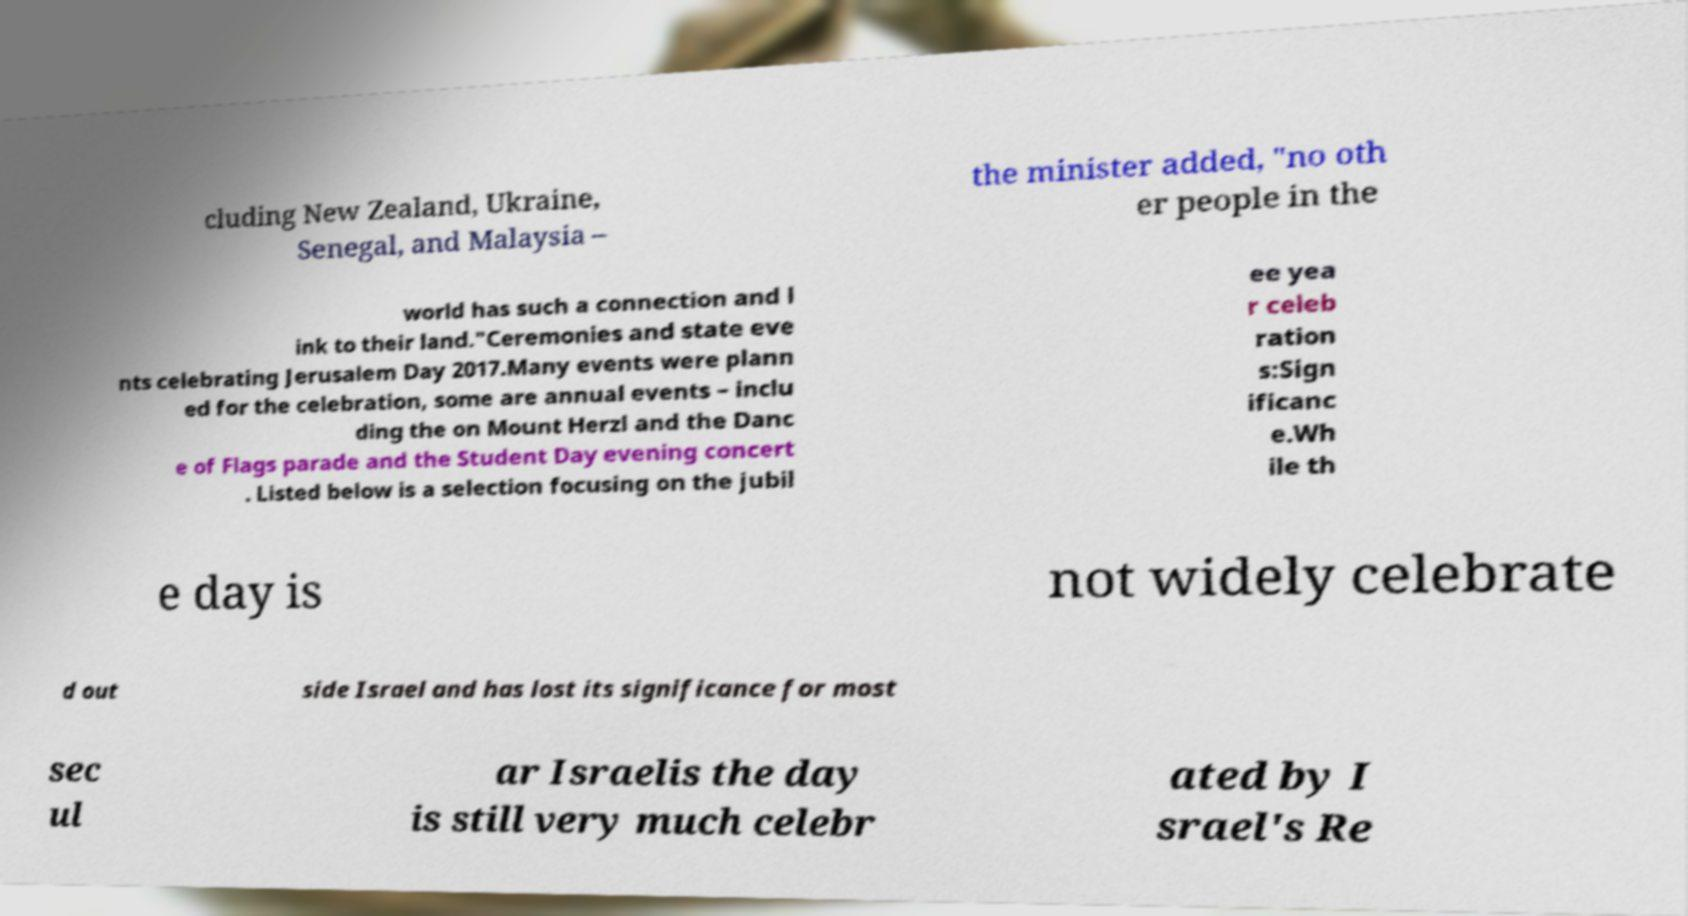I need the written content from this picture converted into text. Can you do that? cluding New Zealand, Ukraine, Senegal, and Malaysia – the minister added, "no oth er people in the world has such a connection and l ink to their land."Ceremonies and state eve nts celebrating Jerusalem Day 2017.Many events were plann ed for the celebration, some are annual events – inclu ding the on Mount Herzl and the Danc e of Flags parade and the Student Day evening concert . Listed below is a selection focusing on the jubil ee yea r celeb ration s:Sign ificanc e.Wh ile th e day is not widely celebrate d out side Israel and has lost its significance for most sec ul ar Israelis the day is still very much celebr ated by I srael's Re 